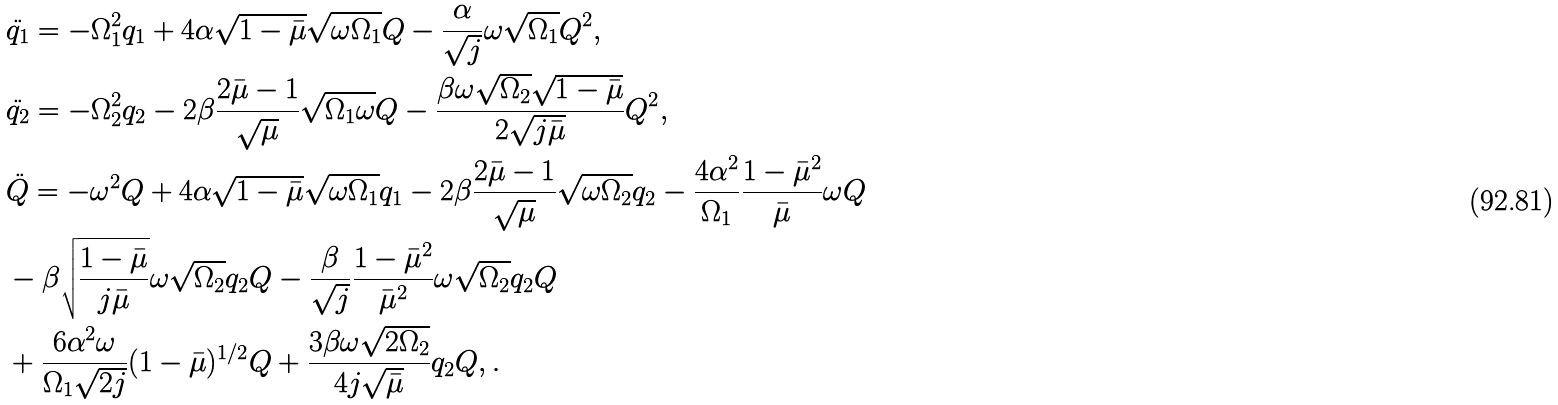<formula> <loc_0><loc_0><loc_500><loc_500>& \ddot { q _ { 1 } } = - \Omega _ { 1 } ^ { 2 } q _ { 1 } + 4 \alpha \sqrt { 1 - \bar { \mu } } \sqrt { \omega \Omega _ { 1 } } Q - \frac { \alpha } { \sqrt { j } } \omega \sqrt { \Omega _ { 1 } } Q ^ { 2 } , \\ & \ddot { q _ { 2 } } = - \Omega _ { 2 } ^ { 2 } q _ { 2 } - 2 \beta \frac { 2 \bar { \mu } - 1 } { \sqrt { \mu } } \sqrt { \Omega _ { 1 } \omega } Q - \frac { \beta \omega \sqrt { \Omega _ { 2 } } \sqrt { 1 - \bar { \mu } } } { 2 \sqrt { j \bar { \mu } } } Q ^ { 2 } , \\ & \ddot { Q } = - \omega ^ { 2 } Q + 4 \alpha \sqrt { 1 - \bar { \mu } } \sqrt { \omega \Omega _ { 1 } } q _ { 1 } - 2 \beta \frac { 2 \bar { \mu } - 1 } { \sqrt { \mu } } \sqrt { \omega \Omega _ { 2 } } q _ { 2 } - \frac { 4 \alpha ^ { 2 } } { \Omega _ { 1 } } \frac { 1 - \bar { \mu } ^ { 2 } } { \bar { \mu } } \omega Q \\ & - \beta \sqrt { \frac { 1 - \bar { \mu } } { j \bar { \mu } } } \omega \sqrt { \Omega _ { 2 } } q _ { 2 } Q - \frac { \beta } { \sqrt { j } } \frac { 1 - \bar { \mu } ^ { 2 } } { { \bar { \mu } } ^ { 2 } } \omega \sqrt { \Omega _ { 2 } } q _ { 2 } Q \\ & + \frac { 6 \alpha ^ { 2 } \omega } { \Omega _ { 1 } \sqrt { 2 j } } ( 1 - \bar { \mu } ) ^ { 1 / 2 } Q + \frac { 3 \beta \omega \sqrt { 2 \Omega _ { 2 } } } { 4 j \sqrt { \bar { \mu } } } q _ { 2 } Q , .</formula> 